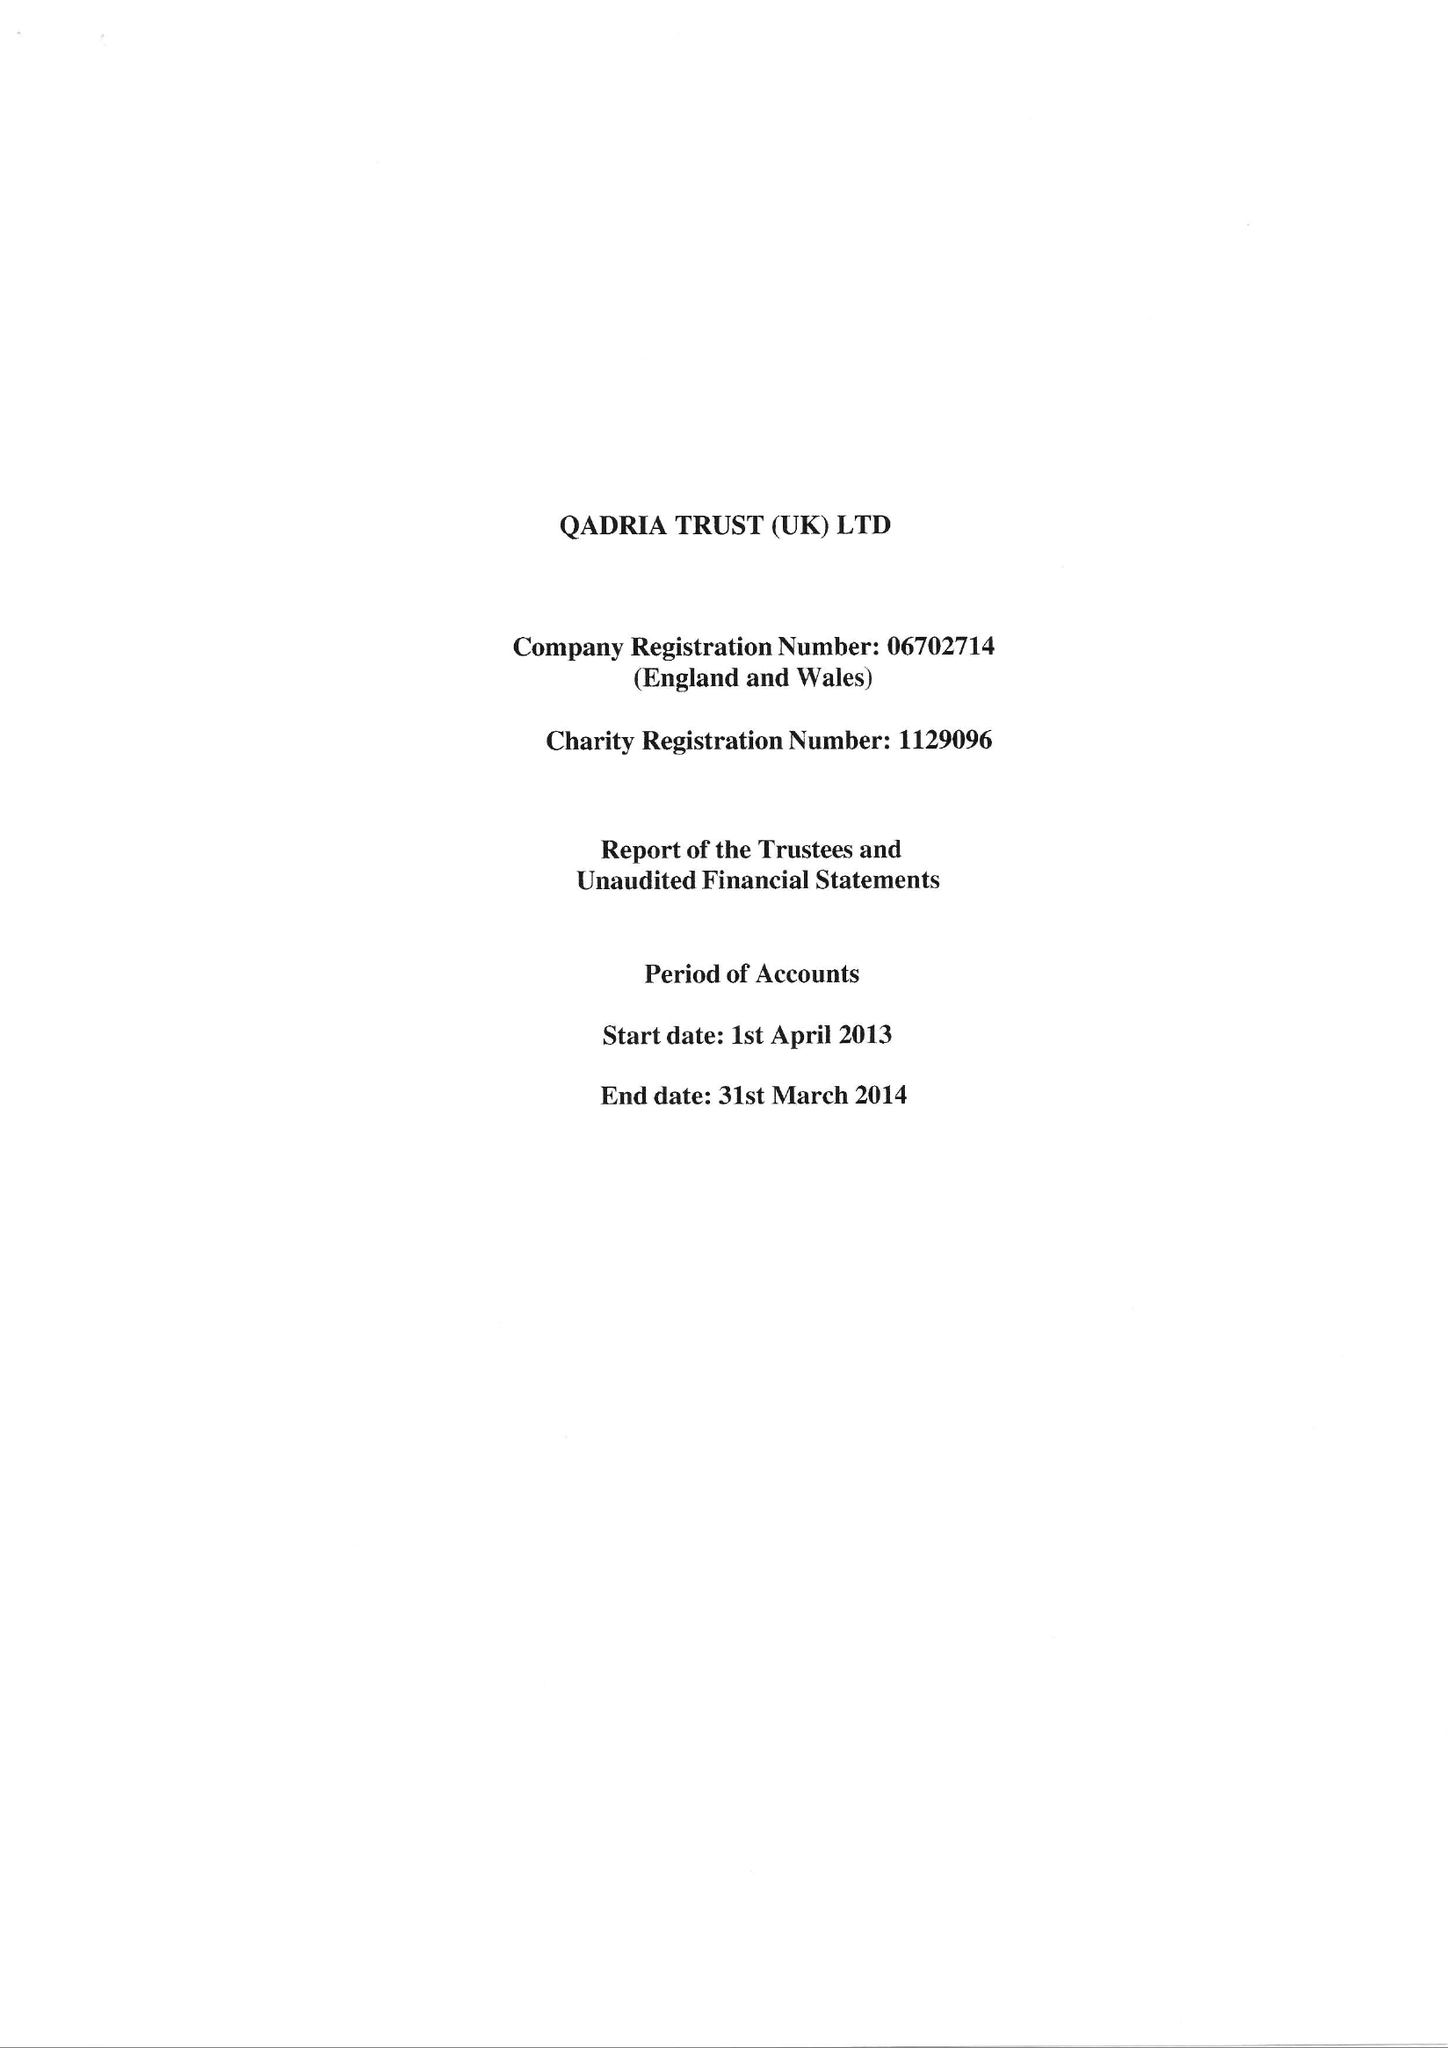What is the value for the address__post_town?
Answer the question using a single word or phrase. BIRMINGHAM 